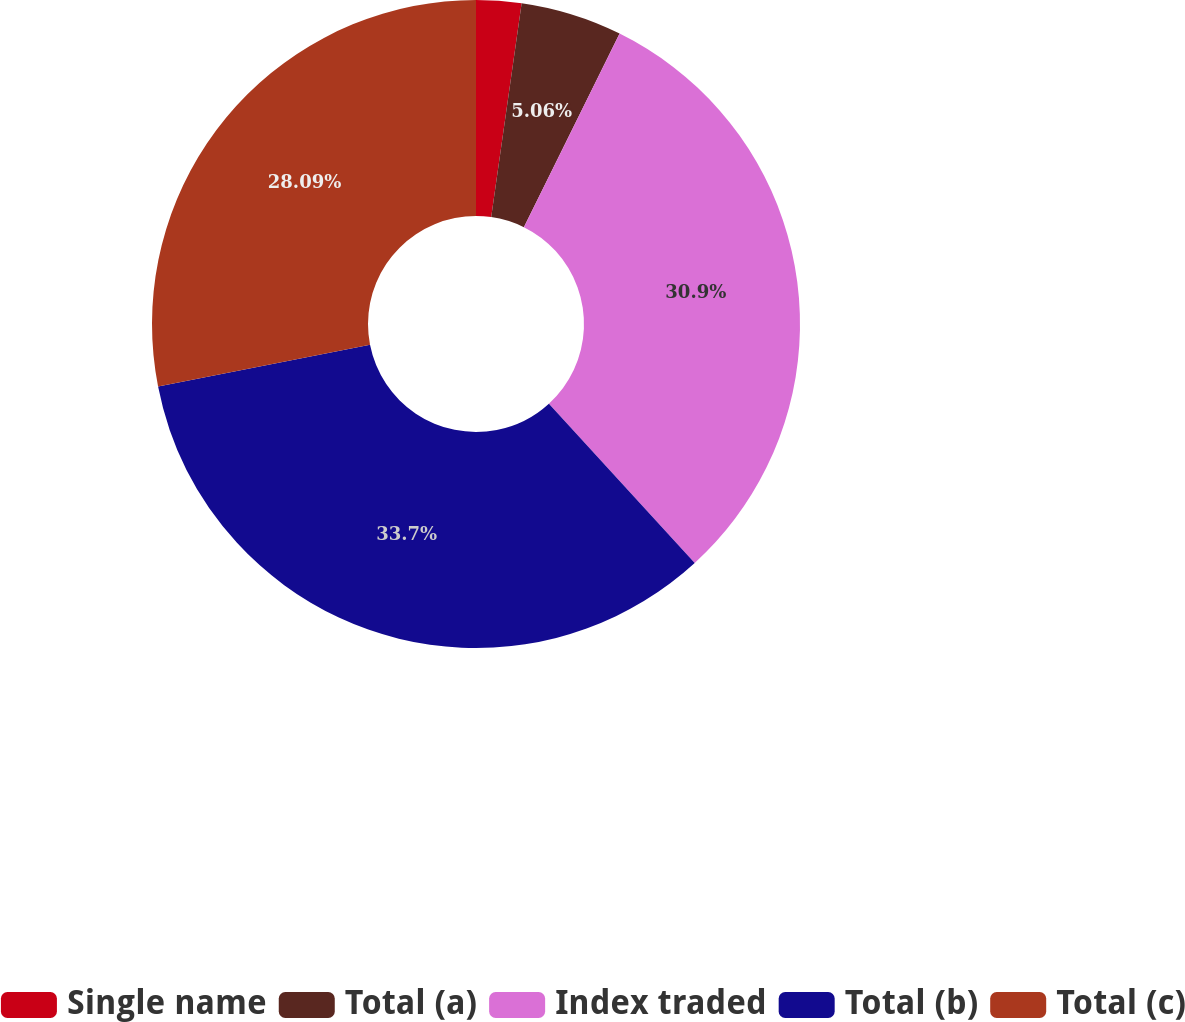Convert chart to OTSL. <chart><loc_0><loc_0><loc_500><loc_500><pie_chart><fcel>Single name<fcel>Total (a)<fcel>Index traded<fcel>Total (b)<fcel>Total (c)<nl><fcel>2.25%<fcel>5.06%<fcel>30.9%<fcel>33.71%<fcel>28.09%<nl></chart> 